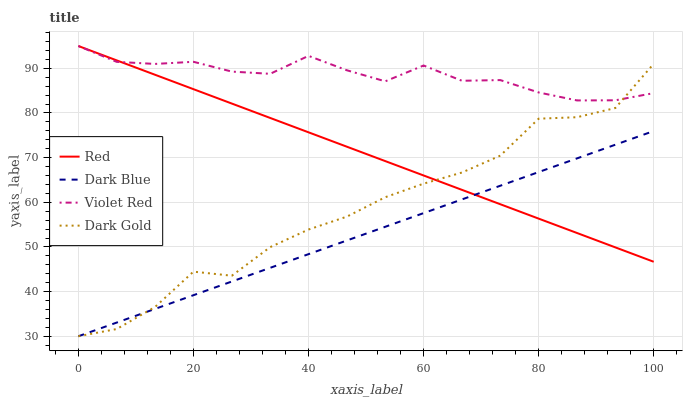Does Dark Blue have the minimum area under the curve?
Answer yes or no. Yes. Does Violet Red have the maximum area under the curve?
Answer yes or no. Yes. Does Red have the minimum area under the curve?
Answer yes or no. No. Does Red have the maximum area under the curve?
Answer yes or no. No. Is Red the smoothest?
Answer yes or no. Yes. Is Dark Gold the roughest?
Answer yes or no. Yes. Is Violet Red the smoothest?
Answer yes or no. No. Is Violet Red the roughest?
Answer yes or no. No. Does Dark Blue have the lowest value?
Answer yes or no. Yes. Does Red have the lowest value?
Answer yes or no. No. Does Red have the highest value?
Answer yes or no. Yes. Does Dark Gold have the highest value?
Answer yes or no. No. Is Dark Blue less than Violet Red?
Answer yes or no. Yes. Is Violet Red greater than Dark Blue?
Answer yes or no. Yes. Does Violet Red intersect Red?
Answer yes or no. Yes. Is Violet Red less than Red?
Answer yes or no. No. Is Violet Red greater than Red?
Answer yes or no. No. Does Dark Blue intersect Violet Red?
Answer yes or no. No. 